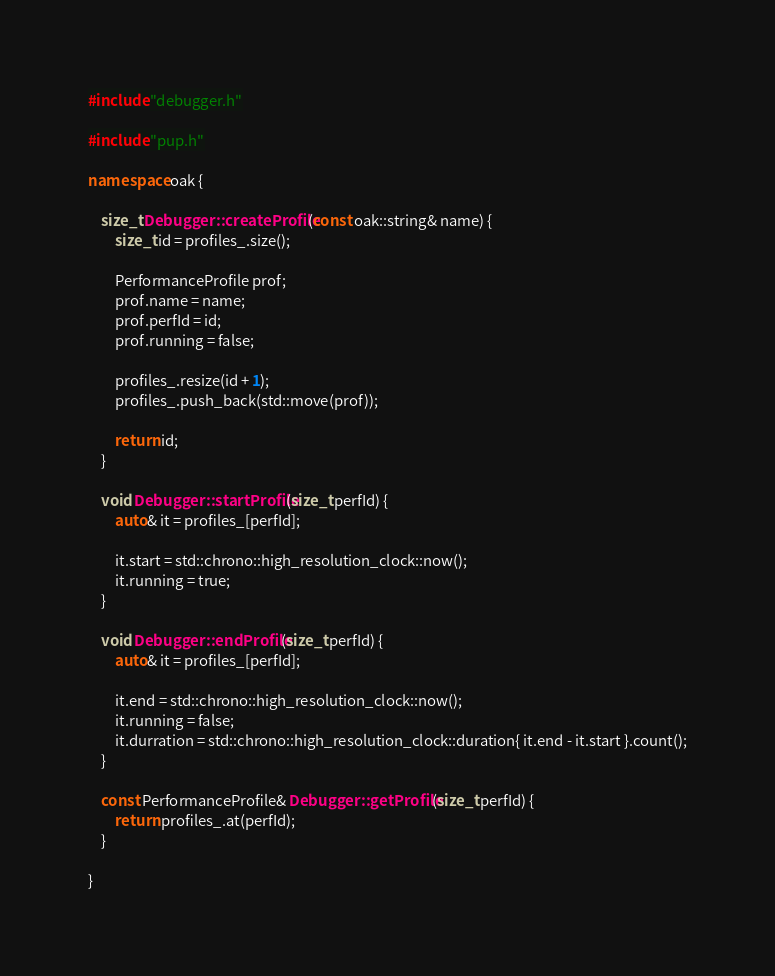<code> <loc_0><loc_0><loc_500><loc_500><_C++_>#include "debugger.h"

#include "pup.h"

namespace oak {

	size_t Debugger::createProfile(const oak::string& name) {
		size_t id = profiles_.size();

		PerformanceProfile prof;
		prof.name = name;
		prof.perfId = id;
		prof.running = false;

		profiles_.resize(id + 1);
		profiles_.push_back(std::move(prof));

		return id;
	}

	void Debugger::startProfile(size_t perfId) {
		auto& it = profiles_[perfId];
		
		it.start = std::chrono::high_resolution_clock::now();
		it.running = true;
	}

	void Debugger::endProfile(size_t perfId) {
		auto& it = profiles_[perfId];

		it.end = std::chrono::high_resolution_clock::now();
		it.running = false;
		it.durration = std::chrono::high_resolution_clock::duration{ it.end - it.start }.count();
	}

	const PerformanceProfile& Debugger::getProfile(size_t perfId) {
		return profiles_.at(perfId);
	}

}</code> 